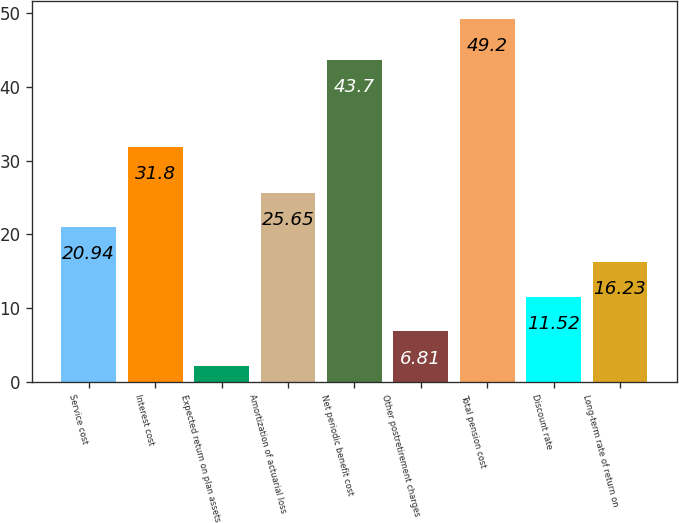Convert chart to OTSL. <chart><loc_0><loc_0><loc_500><loc_500><bar_chart><fcel>Service cost<fcel>Interest cost<fcel>Expected return on plan assets<fcel>Amortization of actuarial loss<fcel>Net periodic benefit cost<fcel>Other postretirement charges<fcel>Total pension cost<fcel>Discount rate<fcel>Long-term rate of return on<nl><fcel>20.94<fcel>31.8<fcel>2.1<fcel>25.65<fcel>43.7<fcel>6.81<fcel>49.2<fcel>11.52<fcel>16.23<nl></chart> 